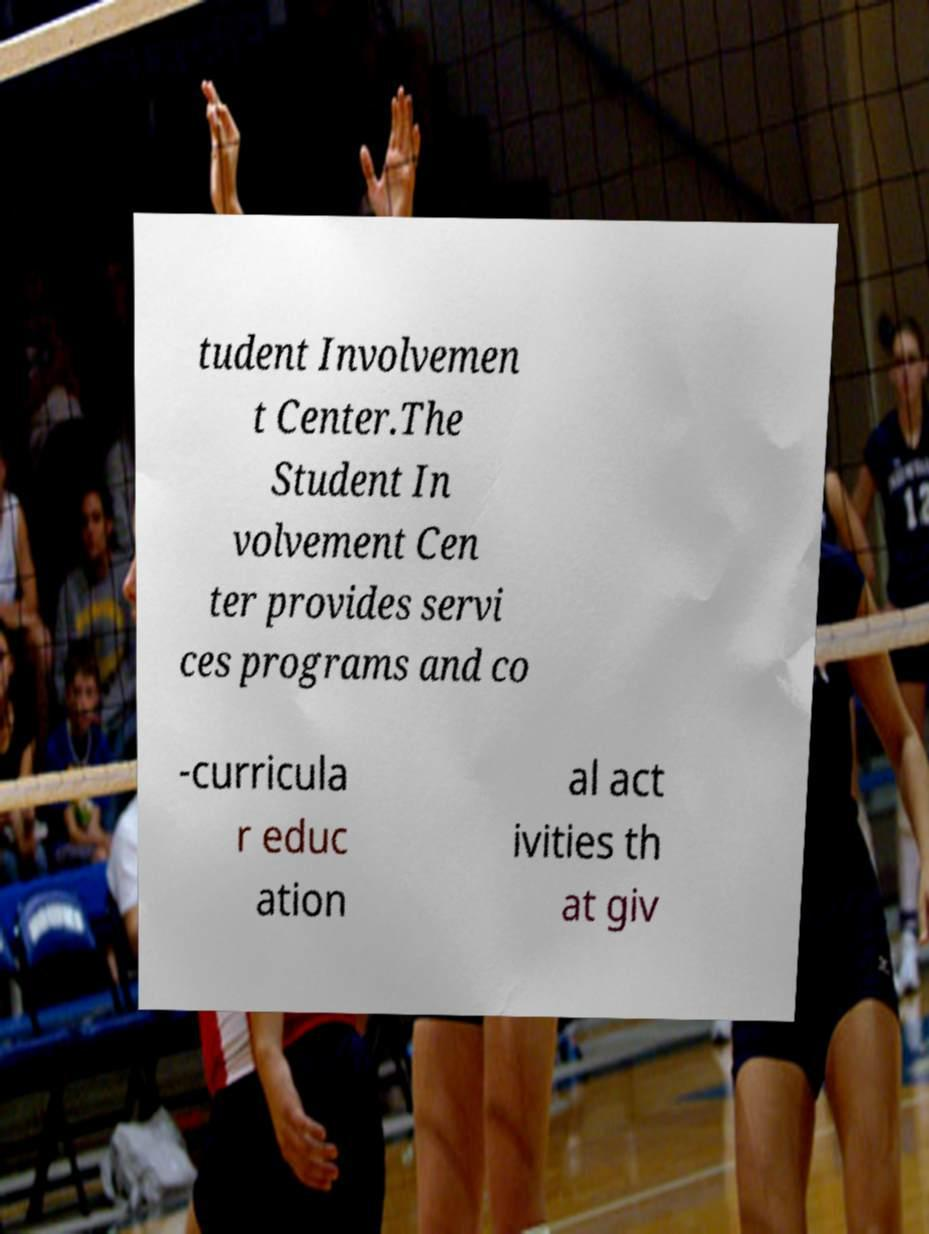Could you assist in decoding the text presented in this image and type it out clearly? tudent Involvemen t Center.The Student In volvement Cen ter provides servi ces programs and co -curricula r educ ation al act ivities th at giv 